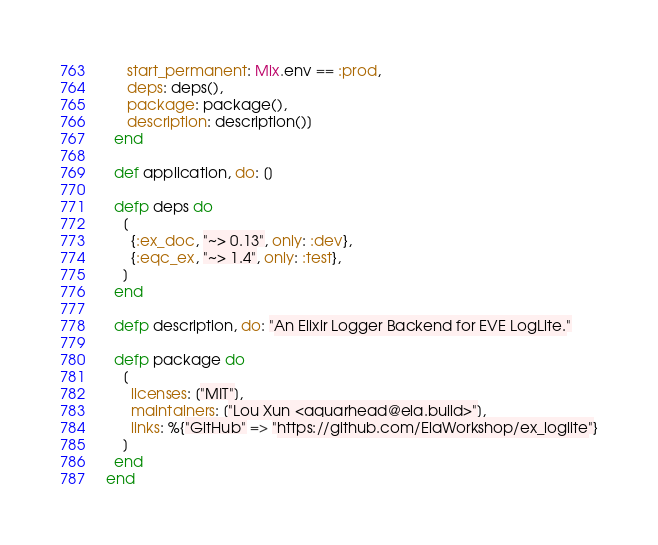<code> <loc_0><loc_0><loc_500><loc_500><_Elixir_>     start_permanent: Mix.env == :prod,
     deps: deps(),
     package: package(),
     description: description()]
  end

  def application, do: []

  defp deps do
    [
      {:ex_doc, "~> 0.13", only: :dev},
      {:eqc_ex, "~> 1.4", only: :test},
    ]
  end

  defp description, do: "An Elixir Logger Backend for EVE LogLite."

  defp package do
    [
      licenses: ["MIT"],
      maintainers: ["Lou Xun <aquarhead@ela.build>"],
      links: %{"GitHub" => "https://github.com/ElaWorkshop/ex_loglite"}
    ]
  end
end
</code> 